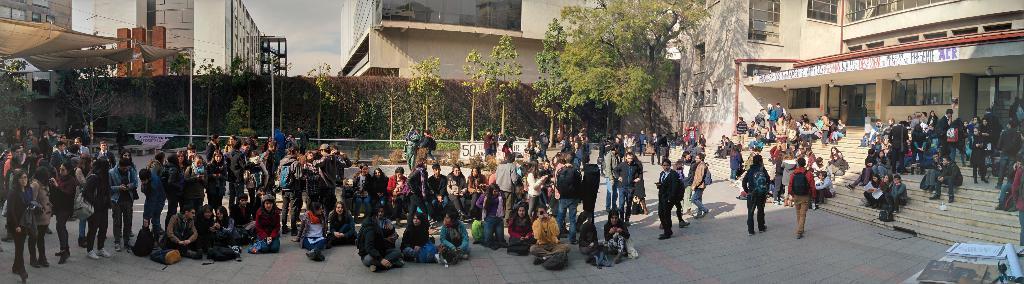Please provide a concise description of this image. In this image I can see number of persons are standing on the ground and few of them are sitting on the ground. To the right bottom of the image I can see few books on the table and few stairs. I can see few buildings, few trees, few poles, few tents which are brown in color, few windows of the building and the sky. 